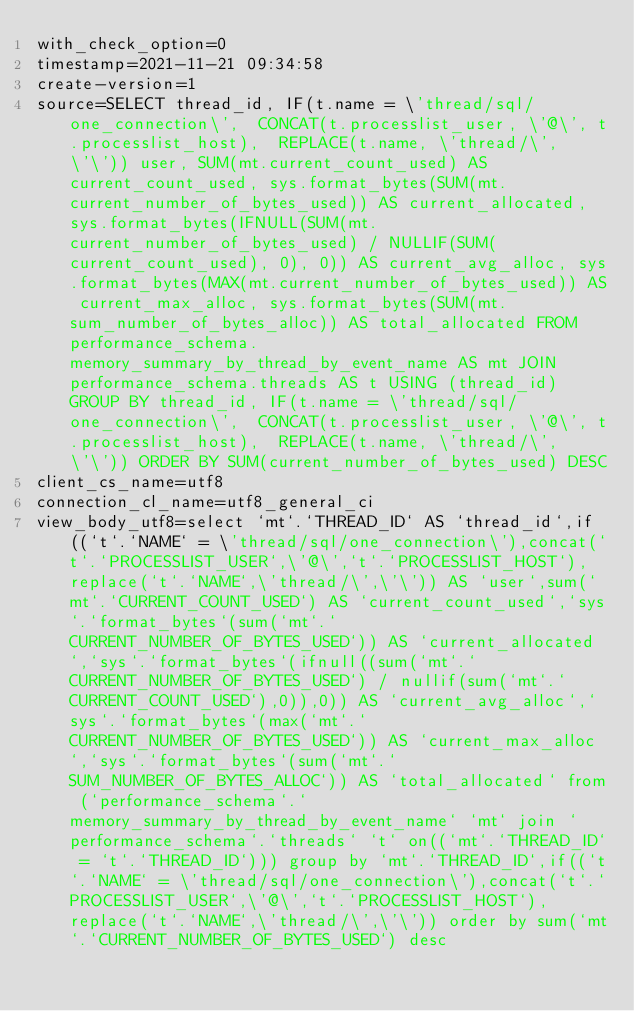<code> <loc_0><loc_0><loc_500><loc_500><_VisualBasic_>with_check_option=0
timestamp=2021-11-21 09:34:58
create-version=1
source=SELECT thread_id, IF(t.name = \'thread/sql/one_connection\',  CONCAT(t.processlist_user, \'@\', t.processlist_host),  REPLACE(t.name, \'thread/\', \'\')) user, SUM(mt.current_count_used) AS current_count_used, sys.format_bytes(SUM(mt.current_number_of_bytes_used)) AS current_allocated, sys.format_bytes(IFNULL(SUM(mt.current_number_of_bytes_used) / NULLIF(SUM(current_count_used), 0), 0)) AS current_avg_alloc, sys.format_bytes(MAX(mt.current_number_of_bytes_used)) AS current_max_alloc, sys.format_bytes(SUM(mt.sum_number_of_bytes_alloc)) AS total_allocated FROM performance_schema.memory_summary_by_thread_by_event_name AS mt JOIN performance_schema.threads AS t USING (thread_id) GROUP BY thread_id, IF(t.name = \'thread/sql/one_connection\',  CONCAT(t.processlist_user, \'@\', t.processlist_host),  REPLACE(t.name, \'thread/\', \'\')) ORDER BY SUM(current_number_of_bytes_used) DESC
client_cs_name=utf8
connection_cl_name=utf8_general_ci
view_body_utf8=select `mt`.`THREAD_ID` AS `thread_id`,if((`t`.`NAME` = \'thread/sql/one_connection\'),concat(`t`.`PROCESSLIST_USER`,\'@\',`t`.`PROCESSLIST_HOST`),replace(`t`.`NAME`,\'thread/\',\'\')) AS `user`,sum(`mt`.`CURRENT_COUNT_USED`) AS `current_count_used`,`sys`.`format_bytes`(sum(`mt`.`CURRENT_NUMBER_OF_BYTES_USED`)) AS `current_allocated`,`sys`.`format_bytes`(ifnull((sum(`mt`.`CURRENT_NUMBER_OF_BYTES_USED`) / nullif(sum(`mt`.`CURRENT_COUNT_USED`),0)),0)) AS `current_avg_alloc`,`sys`.`format_bytes`(max(`mt`.`CURRENT_NUMBER_OF_BYTES_USED`)) AS `current_max_alloc`,`sys`.`format_bytes`(sum(`mt`.`SUM_NUMBER_OF_BYTES_ALLOC`)) AS `total_allocated` from (`performance_schema`.`memory_summary_by_thread_by_event_name` `mt` join `performance_schema`.`threads` `t` on((`mt`.`THREAD_ID` = `t`.`THREAD_ID`))) group by `mt`.`THREAD_ID`,if((`t`.`NAME` = \'thread/sql/one_connection\'),concat(`t`.`PROCESSLIST_USER`,\'@\',`t`.`PROCESSLIST_HOST`),replace(`t`.`NAME`,\'thread/\',\'\')) order by sum(`mt`.`CURRENT_NUMBER_OF_BYTES_USED`) desc
</code> 